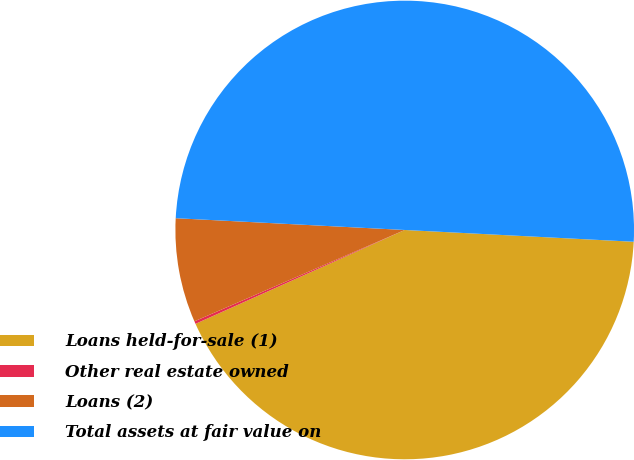<chart> <loc_0><loc_0><loc_500><loc_500><pie_chart><fcel>Loans held-for-sale (1)<fcel>Other real estate owned<fcel>Loans (2)<fcel>Total assets at fair value on<nl><fcel>42.47%<fcel>0.19%<fcel>7.34%<fcel>50.0%<nl></chart> 